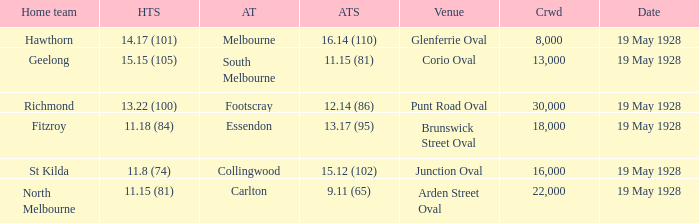What was the listed crowd at junction oval? 16000.0. 